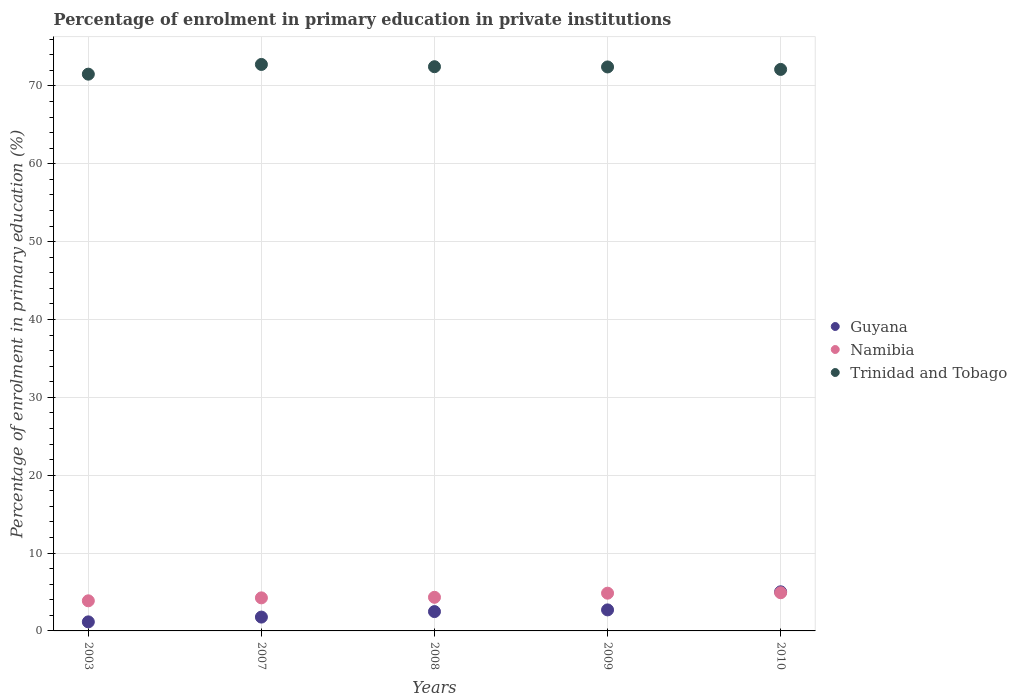How many different coloured dotlines are there?
Your response must be concise. 3. Is the number of dotlines equal to the number of legend labels?
Provide a succinct answer. Yes. What is the percentage of enrolment in primary education in Namibia in 2003?
Offer a very short reply. 3.87. Across all years, what is the maximum percentage of enrolment in primary education in Namibia?
Your response must be concise. 4.9. Across all years, what is the minimum percentage of enrolment in primary education in Trinidad and Tobago?
Ensure brevity in your answer.  71.52. In which year was the percentage of enrolment in primary education in Trinidad and Tobago maximum?
Your answer should be very brief. 2007. In which year was the percentage of enrolment in primary education in Namibia minimum?
Provide a short and direct response. 2003. What is the total percentage of enrolment in primary education in Namibia in the graph?
Make the answer very short. 22.19. What is the difference between the percentage of enrolment in primary education in Guyana in 2009 and that in 2010?
Offer a terse response. -2.32. What is the difference between the percentage of enrolment in primary education in Namibia in 2008 and the percentage of enrolment in primary education in Guyana in 2009?
Provide a short and direct response. 1.62. What is the average percentage of enrolment in primary education in Namibia per year?
Your answer should be very brief. 4.44. In the year 2007, what is the difference between the percentage of enrolment in primary education in Guyana and percentage of enrolment in primary education in Trinidad and Tobago?
Ensure brevity in your answer.  -70.99. What is the ratio of the percentage of enrolment in primary education in Trinidad and Tobago in 2009 to that in 2010?
Your answer should be compact. 1. Is the percentage of enrolment in primary education in Namibia in 2003 less than that in 2008?
Your answer should be very brief. Yes. Is the difference between the percentage of enrolment in primary education in Guyana in 2003 and 2007 greater than the difference between the percentage of enrolment in primary education in Trinidad and Tobago in 2003 and 2007?
Provide a succinct answer. Yes. What is the difference between the highest and the second highest percentage of enrolment in primary education in Namibia?
Make the answer very short. 0.06. What is the difference between the highest and the lowest percentage of enrolment in primary education in Trinidad and Tobago?
Offer a terse response. 1.25. In how many years, is the percentage of enrolment in primary education in Guyana greater than the average percentage of enrolment in primary education in Guyana taken over all years?
Offer a very short reply. 2. How many dotlines are there?
Keep it short and to the point. 3. How many years are there in the graph?
Offer a terse response. 5. Does the graph contain any zero values?
Give a very brief answer. No. Does the graph contain grids?
Provide a short and direct response. Yes. Where does the legend appear in the graph?
Provide a short and direct response. Center right. How many legend labels are there?
Offer a terse response. 3. What is the title of the graph?
Provide a short and direct response. Percentage of enrolment in primary education in private institutions. What is the label or title of the Y-axis?
Your answer should be very brief. Percentage of enrolment in primary education (%). What is the Percentage of enrolment in primary education (%) of Guyana in 2003?
Offer a terse response. 1.16. What is the Percentage of enrolment in primary education (%) of Namibia in 2003?
Your answer should be compact. 3.87. What is the Percentage of enrolment in primary education (%) in Trinidad and Tobago in 2003?
Make the answer very short. 71.52. What is the Percentage of enrolment in primary education (%) of Guyana in 2007?
Offer a terse response. 1.78. What is the Percentage of enrolment in primary education (%) of Namibia in 2007?
Keep it short and to the point. 4.25. What is the Percentage of enrolment in primary education (%) in Trinidad and Tobago in 2007?
Keep it short and to the point. 72.77. What is the Percentage of enrolment in primary education (%) in Guyana in 2008?
Your answer should be compact. 2.48. What is the Percentage of enrolment in primary education (%) in Namibia in 2008?
Your answer should be very brief. 4.32. What is the Percentage of enrolment in primary education (%) of Trinidad and Tobago in 2008?
Your answer should be very brief. 72.48. What is the Percentage of enrolment in primary education (%) in Guyana in 2009?
Provide a succinct answer. 2.7. What is the Percentage of enrolment in primary education (%) of Namibia in 2009?
Your answer should be very brief. 4.85. What is the Percentage of enrolment in primary education (%) of Trinidad and Tobago in 2009?
Your answer should be very brief. 72.45. What is the Percentage of enrolment in primary education (%) in Guyana in 2010?
Provide a succinct answer. 5.02. What is the Percentage of enrolment in primary education (%) in Namibia in 2010?
Provide a short and direct response. 4.9. What is the Percentage of enrolment in primary education (%) in Trinidad and Tobago in 2010?
Provide a short and direct response. 72.13. Across all years, what is the maximum Percentage of enrolment in primary education (%) of Guyana?
Ensure brevity in your answer.  5.02. Across all years, what is the maximum Percentage of enrolment in primary education (%) of Namibia?
Your response must be concise. 4.9. Across all years, what is the maximum Percentage of enrolment in primary education (%) in Trinidad and Tobago?
Offer a terse response. 72.77. Across all years, what is the minimum Percentage of enrolment in primary education (%) in Guyana?
Offer a terse response. 1.16. Across all years, what is the minimum Percentage of enrolment in primary education (%) of Namibia?
Give a very brief answer. 3.87. Across all years, what is the minimum Percentage of enrolment in primary education (%) in Trinidad and Tobago?
Give a very brief answer. 71.52. What is the total Percentage of enrolment in primary education (%) in Guyana in the graph?
Offer a terse response. 13.15. What is the total Percentage of enrolment in primary education (%) of Namibia in the graph?
Offer a terse response. 22.19. What is the total Percentage of enrolment in primary education (%) in Trinidad and Tobago in the graph?
Ensure brevity in your answer.  361.34. What is the difference between the Percentage of enrolment in primary education (%) in Guyana in 2003 and that in 2007?
Your response must be concise. -0.61. What is the difference between the Percentage of enrolment in primary education (%) in Namibia in 2003 and that in 2007?
Make the answer very short. -0.38. What is the difference between the Percentage of enrolment in primary education (%) of Trinidad and Tobago in 2003 and that in 2007?
Your answer should be very brief. -1.25. What is the difference between the Percentage of enrolment in primary education (%) in Guyana in 2003 and that in 2008?
Your response must be concise. -1.32. What is the difference between the Percentage of enrolment in primary education (%) in Namibia in 2003 and that in 2008?
Your answer should be compact. -0.45. What is the difference between the Percentage of enrolment in primary education (%) of Trinidad and Tobago in 2003 and that in 2008?
Your response must be concise. -0.96. What is the difference between the Percentage of enrolment in primary education (%) in Guyana in 2003 and that in 2009?
Provide a short and direct response. -1.54. What is the difference between the Percentage of enrolment in primary education (%) in Namibia in 2003 and that in 2009?
Offer a very short reply. -0.98. What is the difference between the Percentage of enrolment in primary education (%) in Trinidad and Tobago in 2003 and that in 2009?
Offer a very short reply. -0.93. What is the difference between the Percentage of enrolment in primary education (%) in Guyana in 2003 and that in 2010?
Your answer should be compact. -3.86. What is the difference between the Percentage of enrolment in primary education (%) of Namibia in 2003 and that in 2010?
Give a very brief answer. -1.04. What is the difference between the Percentage of enrolment in primary education (%) in Trinidad and Tobago in 2003 and that in 2010?
Offer a very short reply. -0.61. What is the difference between the Percentage of enrolment in primary education (%) in Guyana in 2007 and that in 2008?
Ensure brevity in your answer.  -0.71. What is the difference between the Percentage of enrolment in primary education (%) in Namibia in 2007 and that in 2008?
Ensure brevity in your answer.  -0.07. What is the difference between the Percentage of enrolment in primary education (%) of Trinidad and Tobago in 2007 and that in 2008?
Ensure brevity in your answer.  0.29. What is the difference between the Percentage of enrolment in primary education (%) in Guyana in 2007 and that in 2009?
Your answer should be very brief. -0.92. What is the difference between the Percentage of enrolment in primary education (%) in Namibia in 2007 and that in 2009?
Keep it short and to the point. -0.6. What is the difference between the Percentage of enrolment in primary education (%) of Trinidad and Tobago in 2007 and that in 2009?
Keep it short and to the point. 0.32. What is the difference between the Percentage of enrolment in primary education (%) of Guyana in 2007 and that in 2010?
Make the answer very short. -3.25. What is the difference between the Percentage of enrolment in primary education (%) in Namibia in 2007 and that in 2010?
Your answer should be very brief. -0.66. What is the difference between the Percentage of enrolment in primary education (%) in Trinidad and Tobago in 2007 and that in 2010?
Provide a short and direct response. 0.64. What is the difference between the Percentage of enrolment in primary education (%) of Guyana in 2008 and that in 2009?
Offer a very short reply. -0.22. What is the difference between the Percentage of enrolment in primary education (%) of Namibia in 2008 and that in 2009?
Your answer should be very brief. -0.53. What is the difference between the Percentage of enrolment in primary education (%) of Trinidad and Tobago in 2008 and that in 2009?
Give a very brief answer. 0.03. What is the difference between the Percentage of enrolment in primary education (%) in Guyana in 2008 and that in 2010?
Offer a very short reply. -2.54. What is the difference between the Percentage of enrolment in primary education (%) of Namibia in 2008 and that in 2010?
Provide a succinct answer. -0.59. What is the difference between the Percentage of enrolment in primary education (%) of Trinidad and Tobago in 2008 and that in 2010?
Make the answer very short. 0.35. What is the difference between the Percentage of enrolment in primary education (%) in Guyana in 2009 and that in 2010?
Provide a short and direct response. -2.32. What is the difference between the Percentage of enrolment in primary education (%) in Namibia in 2009 and that in 2010?
Keep it short and to the point. -0.06. What is the difference between the Percentage of enrolment in primary education (%) in Trinidad and Tobago in 2009 and that in 2010?
Make the answer very short. 0.32. What is the difference between the Percentage of enrolment in primary education (%) of Guyana in 2003 and the Percentage of enrolment in primary education (%) of Namibia in 2007?
Offer a very short reply. -3.08. What is the difference between the Percentage of enrolment in primary education (%) of Guyana in 2003 and the Percentage of enrolment in primary education (%) of Trinidad and Tobago in 2007?
Your response must be concise. -71.6. What is the difference between the Percentage of enrolment in primary education (%) of Namibia in 2003 and the Percentage of enrolment in primary education (%) of Trinidad and Tobago in 2007?
Give a very brief answer. -68.9. What is the difference between the Percentage of enrolment in primary education (%) in Guyana in 2003 and the Percentage of enrolment in primary education (%) in Namibia in 2008?
Ensure brevity in your answer.  -3.16. What is the difference between the Percentage of enrolment in primary education (%) in Guyana in 2003 and the Percentage of enrolment in primary education (%) in Trinidad and Tobago in 2008?
Offer a terse response. -71.31. What is the difference between the Percentage of enrolment in primary education (%) of Namibia in 2003 and the Percentage of enrolment in primary education (%) of Trinidad and Tobago in 2008?
Make the answer very short. -68.61. What is the difference between the Percentage of enrolment in primary education (%) of Guyana in 2003 and the Percentage of enrolment in primary education (%) of Namibia in 2009?
Your response must be concise. -3.68. What is the difference between the Percentage of enrolment in primary education (%) in Guyana in 2003 and the Percentage of enrolment in primary education (%) in Trinidad and Tobago in 2009?
Make the answer very short. -71.28. What is the difference between the Percentage of enrolment in primary education (%) of Namibia in 2003 and the Percentage of enrolment in primary education (%) of Trinidad and Tobago in 2009?
Offer a terse response. -68.58. What is the difference between the Percentage of enrolment in primary education (%) of Guyana in 2003 and the Percentage of enrolment in primary education (%) of Namibia in 2010?
Your response must be concise. -3.74. What is the difference between the Percentage of enrolment in primary education (%) in Guyana in 2003 and the Percentage of enrolment in primary education (%) in Trinidad and Tobago in 2010?
Keep it short and to the point. -70.97. What is the difference between the Percentage of enrolment in primary education (%) of Namibia in 2003 and the Percentage of enrolment in primary education (%) of Trinidad and Tobago in 2010?
Keep it short and to the point. -68.26. What is the difference between the Percentage of enrolment in primary education (%) in Guyana in 2007 and the Percentage of enrolment in primary education (%) in Namibia in 2008?
Give a very brief answer. -2.54. What is the difference between the Percentage of enrolment in primary education (%) in Guyana in 2007 and the Percentage of enrolment in primary education (%) in Trinidad and Tobago in 2008?
Provide a succinct answer. -70.7. What is the difference between the Percentage of enrolment in primary education (%) in Namibia in 2007 and the Percentage of enrolment in primary education (%) in Trinidad and Tobago in 2008?
Your answer should be compact. -68.23. What is the difference between the Percentage of enrolment in primary education (%) in Guyana in 2007 and the Percentage of enrolment in primary education (%) in Namibia in 2009?
Make the answer very short. -3.07. What is the difference between the Percentage of enrolment in primary education (%) in Guyana in 2007 and the Percentage of enrolment in primary education (%) in Trinidad and Tobago in 2009?
Your answer should be compact. -70.67. What is the difference between the Percentage of enrolment in primary education (%) in Namibia in 2007 and the Percentage of enrolment in primary education (%) in Trinidad and Tobago in 2009?
Your answer should be compact. -68.2. What is the difference between the Percentage of enrolment in primary education (%) of Guyana in 2007 and the Percentage of enrolment in primary education (%) of Namibia in 2010?
Make the answer very short. -3.13. What is the difference between the Percentage of enrolment in primary education (%) of Guyana in 2007 and the Percentage of enrolment in primary education (%) of Trinidad and Tobago in 2010?
Provide a short and direct response. -70.35. What is the difference between the Percentage of enrolment in primary education (%) of Namibia in 2007 and the Percentage of enrolment in primary education (%) of Trinidad and Tobago in 2010?
Offer a terse response. -67.88. What is the difference between the Percentage of enrolment in primary education (%) of Guyana in 2008 and the Percentage of enrolment in primary education (%) of Namibia in 2009?
Ensure brevity in your answer.  -2.36. What is the difference between the Percentage of enrolment in primary education (%) of Guyana in 2008 and the Percentage of enrolment in primary education (%) of Trinidad and Tobago in 2009?
Your response must be concise. -69.96. What is the difference between the Percentage of enrolment in primary education (%) of Namibia in 2008 and the Percentage of enrolment in primary education (%) of Trinidad and Tobago in 2009?
Offer a terse response. -68.13. What is the difference between the Percentage of enrolment in primary education (%) in Guyana in 2008 and the Percentage of enrolment in primary education (%) in Namibia in 2010?
Give a very brief answer. -2.42. What is the difference between the Percentage of enrolment in primary education (%) of Guyana in 2008 and the Percentage of enrolment in primary education (%) of Trinidad and Tobago in 2010?
Keep it short and to the point. -69.65. What is the difference between the Percentage of enrolment in primary education (%) in Namibia in 2008 and the Percentage of enrolment in primary education (%) in Trinidad and Tobago in 2010?
Your response must be concise. -67.81. What is the difference between the Percentage of enrolment in primary education (%) of Guyana in 2009 and the Percentage of enrolment in primary education (%) of Namibia in 2010?
Provide a short and direct response. -2.2. What is the difference between the Percentage of enrolment in primary education (%) of Guyana in 2009 and the Percentage of enrolment in primary education (%) of Trinidad and Tobago in 2010?
Provide a succinct answer. -69.43. What is the difference between the Percentage of enrolment in primary education (%) of Namibia in 2009 and the Percentage of enrolment in primary education (%) of Trinidad and Tobago in 2010?
Keep it short and to the point. -67.28. What is the average Percentage of enrolment in primary education (%) of Guyana per year?
Offer a very short reply. 2.63. What is the average Percentage of enrolment in primary education (%) of Namibia per year?
Ensure brevity in your answer.  4.44. What is the average Percentage of enrolment in primary education (%) of Trinidad and Tobago per year?
Provide a short and direct response. 72.27. In the year 2003, what is the difference between the Percentage of enrolment in primary education (%) of Guyana and Percentage of enrolment in primary education (%) of Namibia?
Your answer should be very brief. -2.7. In the year 2003, what is the difference between the Percentage of enrolment in primary education (%) of Guyana and Percentage of enrolment in primary education (%) of Trinidad and Tobago?
Your answer should be very brief. -70.36. In the year 2003, what is the difference between the Percentage of enrolment in primary education (%) in Namibia and Percentage of enrolment in primary education (%) in Trinidad and Tobago?
Offer a terse response. -67.65. In the year 2007, what is the difference between the Percentage of enrolment in primary education (%) of Guyana and Percentage of enrolment in primary education (%) of Namibia?
Your answer should be compact. -2.47. In the year 2007, what is the difference between the Percentage of enrolment in primary education (%) in Guyana and Percentage of enrolment in primary education (%) in Trinidad and Tobago?
Ensure brevity in your answer.  -70.99. In the year 2007, what is the difference between the Percentage of enrolment in primary education (%) of Namibia and Percentage of enrolment in primary education (%) of Trinidad and Tobago?
Offer a very short reply. -68.52. In the year 2008, what is the difference between the Percentage of enrolment in primary education (%) in Guyana and Percentage of enrolment in primary education (%) in Namibia?
Offer a terse response. -1.84. In the year 2008, what is the difference between the Percentage of enrolment in primary education (%) in Guyana and Percentage of enrolment in primary education (%) in Trinidad and Tobago?
Your answer should be very brief. -69.99. In the year 2008, what is the difference between the Percentage of enrolment in primary education (%) of Namibia and Percentage of enrolment in primary education (%) of Trinidad and Tobago?
Your answer should be compact. -68.16. In the year 2009, what is the difference between the Percentage of enrolment in primary education (%) in Guyana and Percentage of enrolment in primary education (%) in Namibia?
Your answer should be very brief. -2.15. In the year 2009, what is the difference between the Percentage of enrolment in primary education (%) in Guyana and Percentage of enrolment in primary education (%) in Trinidad and Tobago?
Offer a very short reply. -69.74. In the year 2009, what is the difference between the Percentage of enrolment in primary education (%) in Namibia and Percentage of enrolment in primary education (%) in Trinidad and Tobago?
Make the answer very short. -67.6. In the year 2010, what is the difference between the Percentage of enrolment in primary education (%) of Guyana and Percentage of enrolment in primary education (%) of Namibia?
Ensure brevity in your answer.  0.12. In the year 2010, what is the difference between the Percentage of enrolment in primary education (%) in Guyana and Percentage of enrolment in primary education (%) in Trinidad and Tobago?
Your answer should be compact. -67.1. In the year 2010, what is the difference between the Percentage of enrolment in primary education (%) of Namibia and Percentage of enrolment in primary education (%) of Trinidad and Tobago?
Make the answer very short. -67.22. What is the ratio of the Percentage of enrolment in primary education (%) of Guyana in 2003 to that in 2007?
Offer a terse response. 0.65. What is the ratio of the Percentage of enrolment in primary education (%) in Namibia in 2003 to that in 2007?
Keep it short and to the point. 0.91. What is the ratio of the Percentage of enrolment in primary education (%) in Trinidad and Tobago in 2003 to that in 2007?
Offer a very short reply. 0.98. What is the ratio of the Percentage of enrolment in primary education (%) in Guyana in 2003 to that in 2008?
Offer a very short reply. 0.47. What is the ratio of the Percentage of enrolment in primary education (%) in Namibia in 2003 to that in 2008?
Your response must be concise. 0.9. What is the ratio of the Percentage of enrolment in primary education (%) in Trinidad and Tobago in 2003 to that in 2008?
Ensure brevity in your answer.  0.99. What is the ratio of the Percentage of enrolment in primary education (%) of Guyana in 2003 to that in 2009?
Provide a short and direct response. 0.43. What is the ratio of the Percentage of enrolment in primary education (%) of Namibia in 2003 to that in 2009?
Ensure brevity in your answer.  0.8. What is the ratio of the Percentage of enrolment in primary education (%) in Trinidad and Tobago in 2003 to that in 2009?
Your answer should be very brief. 0.99. What is the ratio of the Percentage of enrolment in primary education (%) of Guyana in 2003 to that in 2010?
Provide a short and direct response. 0.23. What is the ratio of the Percentage of enrolment in primary education (%) of Namibia in 2003 to that in 2010?
Make the answer very short. 0.79. What is the ratio of the Percentage of enrolment in primary education (%) in Trinidad and Tobago in 2003 to that in 2010?
Offer a terse response. 0.99. What is the ratio of the Percentage of enrolment in primary education (%) in Guyana in 2007 to that in 2008?
Make the answer very short. 0.72. What is the ratio of the Percentage of enrolment in primary education (%) in Namibia in 2007 to that in 2008?
Offer a terse response. 0.98. What is the ratio of the Percentage of enrolment in primary education (%) of Guyana in 2007 to that in 2009?
Ensure brevity in your answer.  0.66. What is the ratio of the Percentage of enrolment in primary education (%) in Namibia in 2007 to that in 2009?
Your answer should be very brief. 0.88. What is the ratio of the Percentage of enrolment in primary education (%) in Trinidad and Tobago in 2007 to that in 2009?
Your answer should be very brief. 1. What is the ratio of the Percentage of enrolment in primary education (%) in Guyana in 2007 to that in 2010?
Keep it short and to the point. 0.35. What is the ratio of the Percentage of enrolment in primary education (%) in Namibia in 2007 to that in 2010?
Your answer should be very brief. 0.87. What is the ratio of the Percentage of enrolment in primary education (%) of Trinidad and Tobago in 2007 to that in 2010?
Make the answer very short. 1.01. What is the ratio of the Percentage of enrolment in primary education (%) of Guyana in 2008 to that in 2009?
Make the answer very short. 0.92. What is the ratio of the Percentage of enrolment in primary education (%) of Namibia in 2008 to that in 2009?
Provide a short and direct response. 0.89. What is the ratio of the Percentage of enrolment in primary education (%) in Guyana in 2008 to that in 2010?
Your answer should be compact. 0.49. What is the ratio of the Percentage of enrolment in primary education (%) of Namibia in 2008 to that in 2010?
Your response must be concise. 0.88. What is the ratio of the Percentage of enrolment in primary education (%) in Guyana in 2009 to that in 2010?
Your response must be concise. 0.54. What is the ratio of the Percentage of enrolment in primary education (%) in Namibia in 2009 to that in 2010?
Make the answer very short. 0.99. What is the difference between the highest and the second highest Percentage of enrolment in primary education (%) of Guyana?
Provide a succinct answer. 2.32. What is the difference between the highest and the second highest Percentage of enrolment in primary education (%) in Namibia?
Provide a succinct answer. 0.06. What is the difference between the highest and the second highest Percentage of enrolment in primary education (%) of Trinidad and Tobago?
Provide a short and direct response. 0.29. What is the difference between the highest and the lowest Percentage of enrolment in primary education (%) in Guyana?
Keep it short and to the point. 3.86. What is the difference between the highest and the lowest Percentage of enrolment in primary education (%) of Namibia?
Your answer should be very brief. 1.04. What is the difference between the highest and the lowest Percentage of enrolment in primary education (%) of Trinidad and Tobago?
Provide a succinct answer. 1.25. 